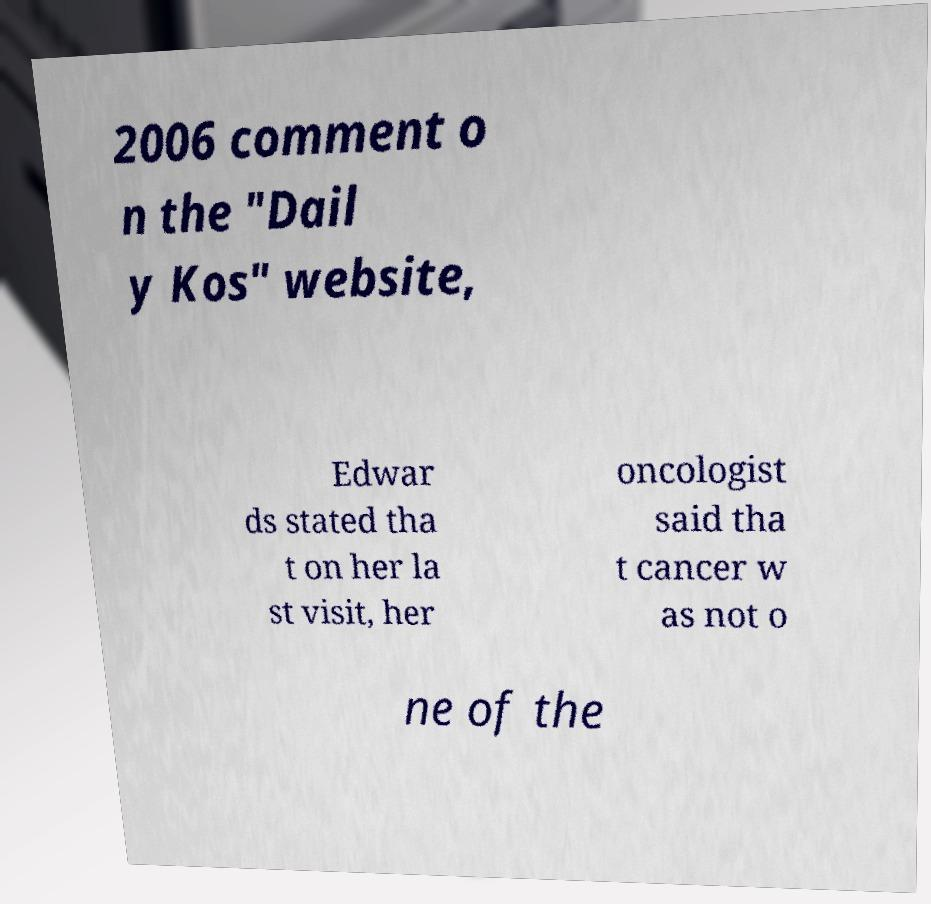There's text embedded in this image that I need extracted. Can you transcribe it verbatim? 2006 comment o n the "Dail y Kos" website, Edwar ds stated tha t on her la st visit, her oncologist said tha t cancer w as not o ne of the 